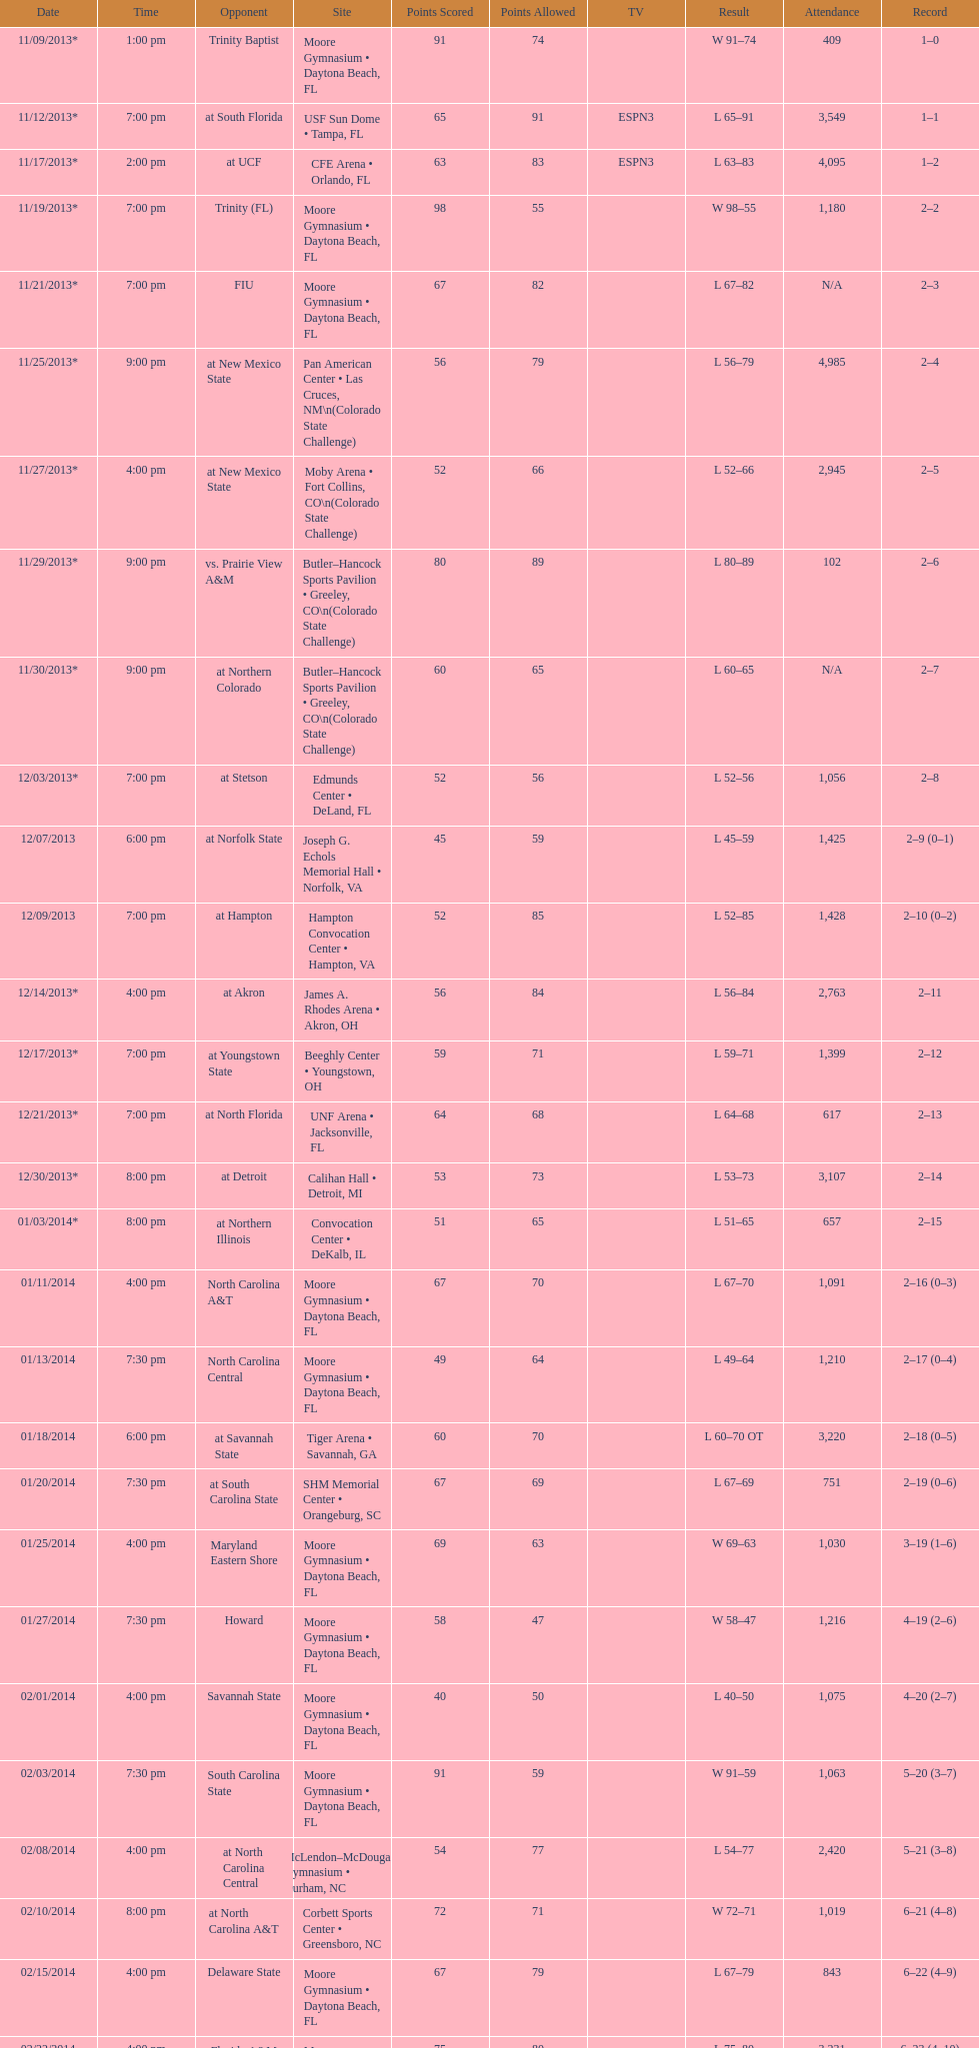How much larger was the attendance on 11/25/2013 than 12/21/2013? 4368. Can you parse all the data within this table? {'header': ['Date', 'Time', 'Opponent', 'Site', 'Points Scored', 'Points Allowed', 'TV', 'Result', 'Attendance', 'Record'], 'rows': [['11/09/2013*', '1:00 pm', 'Trinity Baptist', 'Moore Gymnasium • Daytona Beach, FL', '91', '74', '', 'W\xa091–74', '409', '1–0'], ['11/12/2013*', '7:00 pm', 'at\xa0South Florida', 'USF Sun Dome • Tampa, FL', '65', '91', 'ESPN3', 'L\xa065–91', '3,549', '1–1'], ['11/17/2013*', '2:00 pm', 'at\xa0UCF', 'CFE Arena • Orlando, FL', '63', '83', 'ESPN3', 'L\xa063–83', '4,095', '1–2'], ['11/19/2013*', '7:00 pm', 'Trinity (FL)', 'Moore Gymnasium • Daytona Beach, FL', '98', '55', '', 'W\xa098–55', '1,180', '2–2'], ['11/21/2013*', '7:00 pm', 'FIU', 'Moore Gymnasium • Daytona Beach, FL', '67', '82', '', 'L\xa067–82', 'N/A', '2–3'], ['11/25/2013*', '9:00 pm', 'at\xa0New Mexico State', 'Pan American Center • Las Cruces, NM\\n(Colorado State Challenge)', '56', '79', '', 'L\xa056–79', '4,985', '2–4'], ['11/27/2013*', '4:00 pm', 'at\xa0New Mexico State', 'Moby Arena • Fort Collins, CO\\n(Colorado State Challenge)', '52', '66', '', 'L\xa052–66', '2,945', '2–5'], ['11/29/2013*', '9:00 pm', 'vs.\xa0Prairie View A&M', 'Butler–Hancock Sports Pavilion • Greeley, CO\\n(Colorado State Challenge)', '80', '89', '', 'L\xa080–89', '102', '2–6'], ['11/30/2013*', '9:00 pm', 'at\xa0Northern Colorado', 'Butler–Hancock Sports Pavilion • Greeley, CO\\n(Colorado State Challenge)', '60', '65', '', 'L\xa060–65', 'N/A', '2–7'], ['12/03/2013*', '7:00 pm', 'at\xa0Stetson', 'Edmunds Center • DeLand, FL', '52', '56', '', 'L\xa052–56', '1,056', '2–8'], ['12/07/2013', '6:00 pm', 'at\xa0Norfolk State', 'Joseph G. Echols Memorial Hall • Norfolk, VA', '45', '59', '', 'L\xa045–59', '1,425', '2–9 (0–1)'], ['12/09/2013', '7:00 pm', 'at\xa0Hampton', 'Hampton Convocation Center • Hampton, VA', '52', '85', '', 'L\xa052–85', '1,428', '2–10 (0–2)'], ['12/14/2013*', '4:00 pm', 'at\xa0Akron', 'James A. Rhodes Arena • Akron, OH', '56', '84', '', 'L\xa056–84', '2,763', '2–11'], ['12/17/2013*', '7:00 pm', 'at\xa0Youngstown State', 'Beeghly Center • Youngstown, OH', '59', '71', '', 'L\xa059–71', '1,399', '2–12'], ['12/21/2013*', '7:00 pm', 'at\xa0North Florida', 'UNF Arena • Jacksonville, FL', '64', '68', '', 'L\xa064–68', '617', '2–13'], ['12/30/2013*', '8:00 pm', 'at\xa0Detroit', 'Calihan Hall • Detroit, MI', '53', '73', '', 'L\xa053–73', '3,107', '2–14'], ['01/03/2014*', '8:00 pm', 'at\xa0Northern Illinois', 'Convocation Center • DeKalb, IL', '51', '65', '', 'L\xa051–65', '657', '2–15'], ['01/11/2014', '4:00 pm', 'North Carolina A&T', 'Moore Gymnasium • Daytona Beach, FL', '67', '70', '', 'L\xa067–70', '1,091', '2–16 (0–3)'], ['01/13/2014', '7:30 pm', 'North Carolina Central', 'Moore Gymnasium • Daytona Beach, FL', '49', '64', '', 'L\xa049–64', '1,210', '2–17 (0–4)'], ['01/18/2014', '6:00 pm', 'at\xa0Savannah State', 'Tiger Arena • Savannah, GA', '60', '70', '', 'L\xa060–70\xa0OT', '3,220', '2–18 (0–5)'], ['01/20/2014', '7:30 pm', 'at\xa0South Carolina State', 'SHM Memorial Center • Orangeburg, SC', '67', '69', '', 'L\xa067–69', '751', '2–19 (0–6)'], ['01/25/2014', '4:00 pm', 'Maryland Eastern Shore', 'Moore Gymnasium • Daytona Beach, FL', '69', '63', '', 'W\xa069–63', '1,030', '3–19 (1–6)'], ['01/27/2014', '7:30 pm', 'Howard', 'Moore Gymnasium • Daytona Beach, FL', '58', '47', '', 'W\xa058–47', '1,216', '4–19 (2–6)'], ['02/01/2014', '4:00 pm', 'Savannah State', 'Moore Gymnasium • Daytona Beach, FL', '40', '50', '', 'L\xa040–50', '1,075', '4–20 (2–7)'], ['02/03/2014', '7:30 pm', 'South Carolina State', 'Moore Gymnasium • Daytona Beach, FL', '91', '59', '', 'W\xa091–59', '1,063', '5–20 (3–7)'], ['02/08/2014', '4:00 pm', 'at\xa0North Carolina Central', 'McLendon–McDougald Gymnasium • Durham, NC', '54', '77', '', 'L\xa054–77', '2,420', '5–21 (3–8)'], ['02/10/2014', '8:00 pm', 'at\xa0North Carolina A&T', 'Corbett Sports Center • Greensboro, NC', '72', '71', '', 'W\xa072–71', '1,019', '6–21 (4–8)'], ['02/15/2014', '4:00 pm', 'Delaware State', 'Moore Gymnasium • Daytona Beach, FL', '67', '79', '', 'L\xa067–79', '843', '6–22 (4–9)'], ['02/22/2014', '4:00 pm', 'Florida A&M', 'Moore Gymnasium • Daytona Beach, FL', '75', '80', '', 'L\xa075–80', '3,231', '6–23 (4–10)'], ['03/01/2014', '4:00 pm', 'at\xa0Morgan State', 'Talmadge L. Hill Field House • Baltimore, MD', '61', '65', '', 'L\xa061–65', '2,056', '6–24 (4–11)'], ['03/06/2014', '7:30 pm', 'at\xa0Florida A&M', 'Teaching Gym • Tallahassee, FL', '70', '68', '', 'W\xa070–68', '2,376', '7–24 (5–11)'], ['03/11/2014', '6:30 pm', 'vs.\xa0Coppin State', 'Norfolk Scope • Norfolk, VA\\n(First round)', '68', '75', '', 'L\xa068–75', '4,658', '7–25']]} 